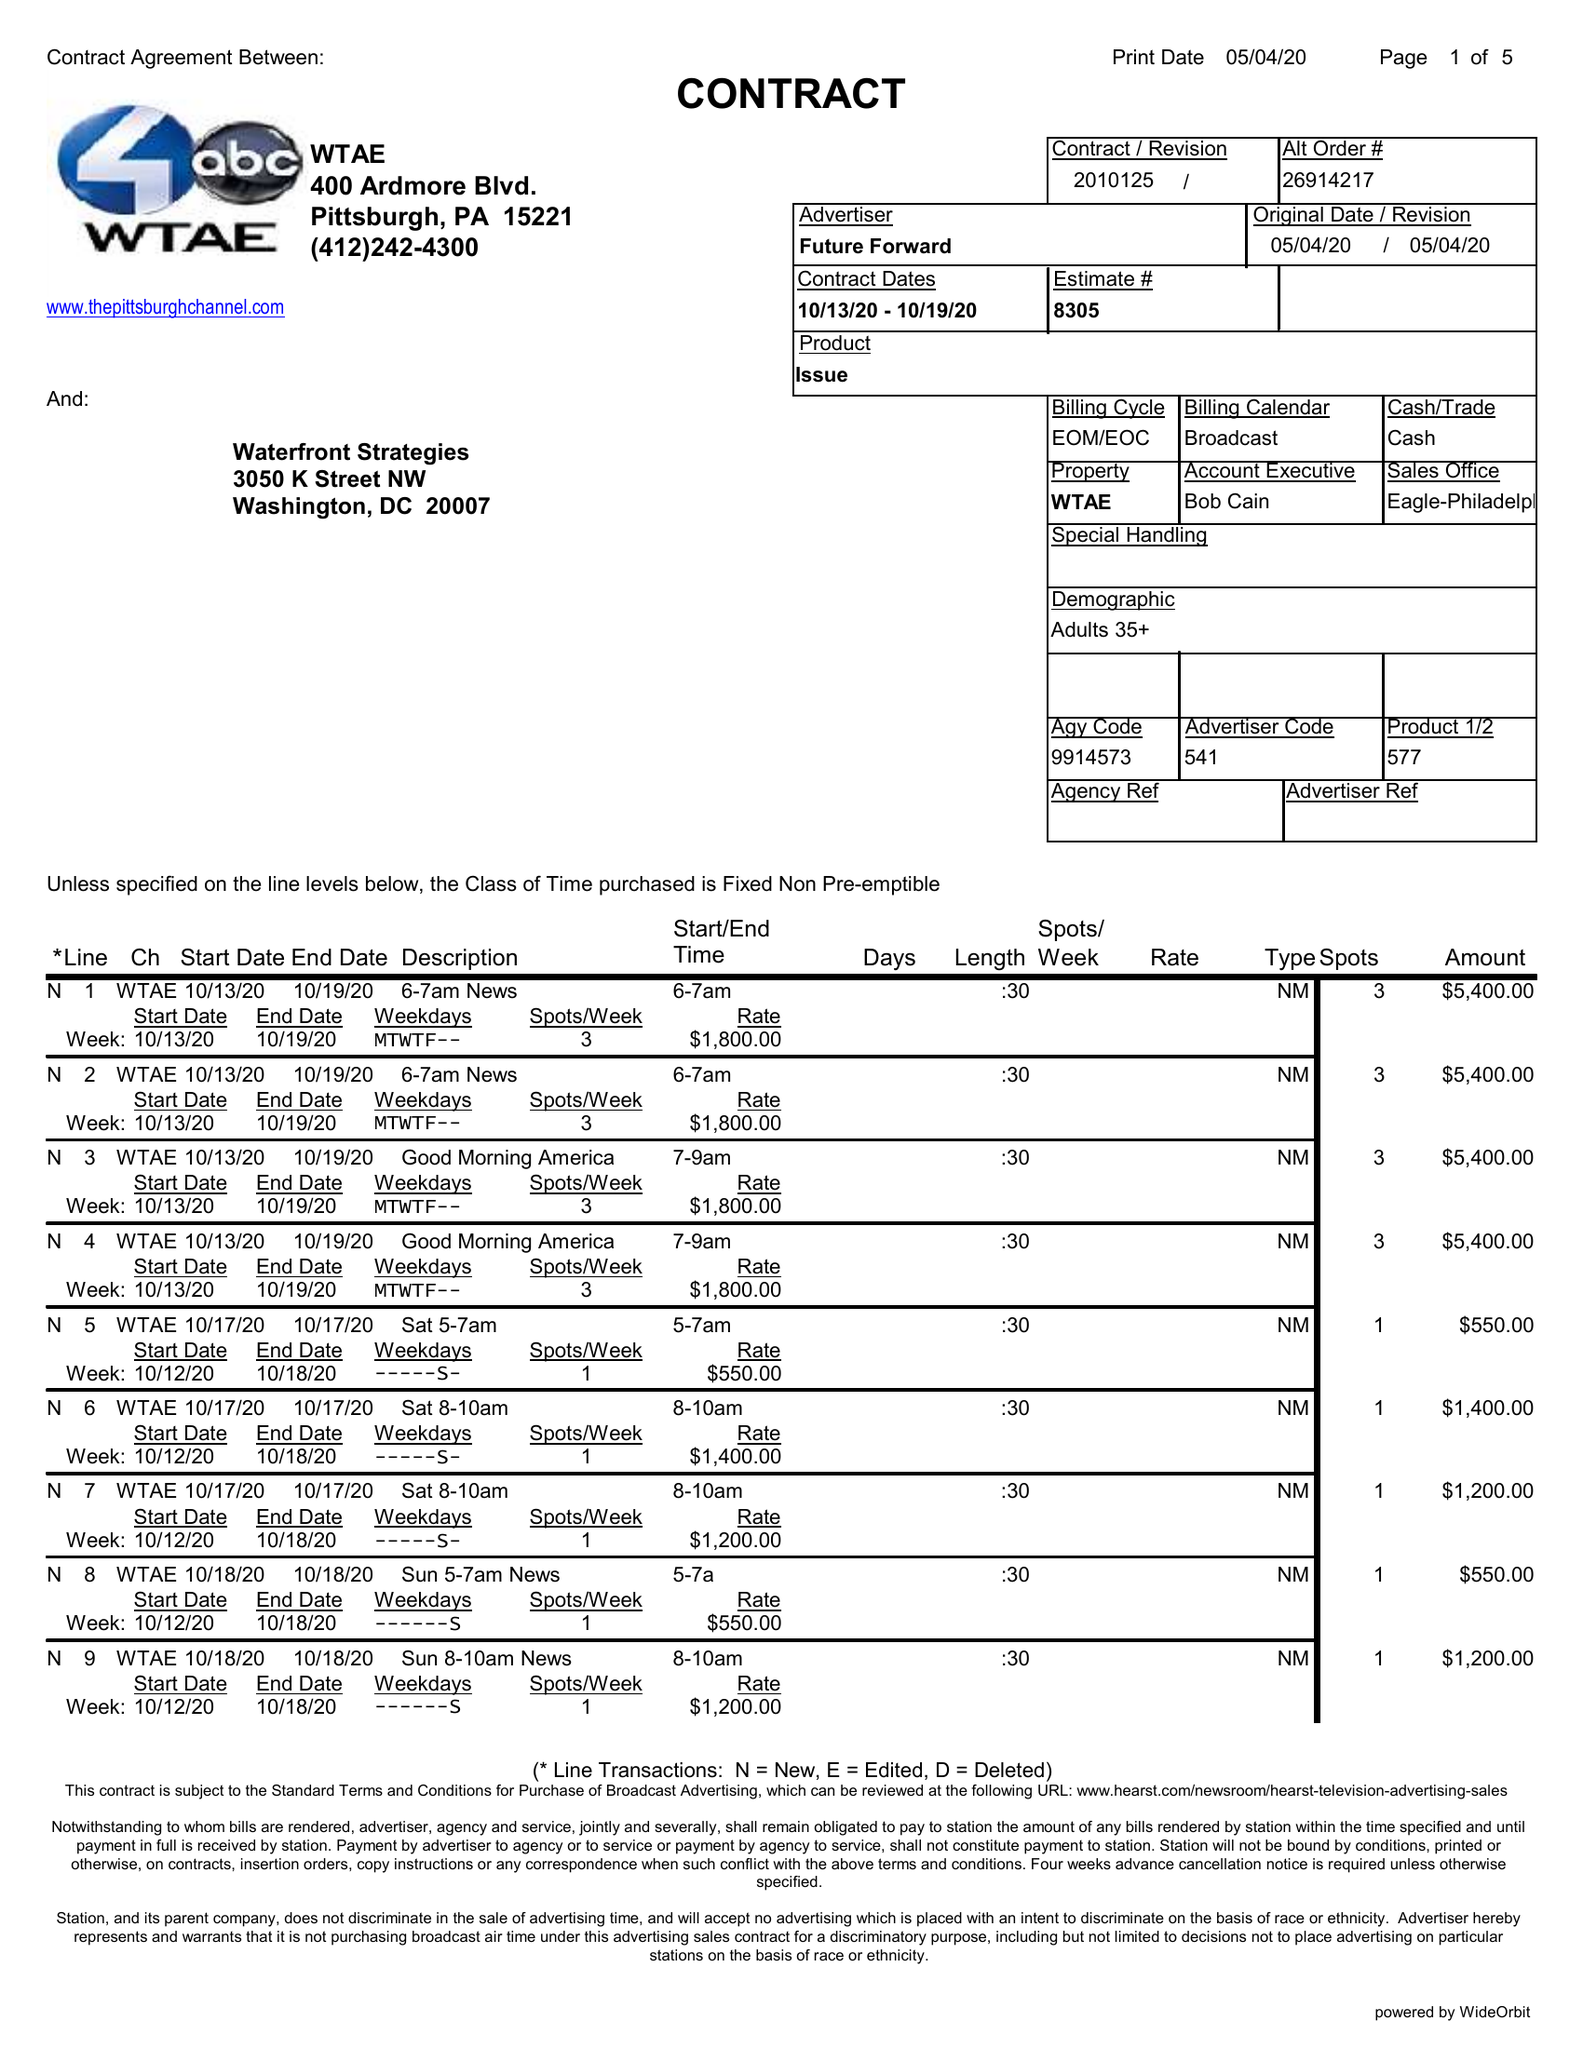What is the value for the gross_amount?
Answer the question using a single word or phrase. 94850.00 